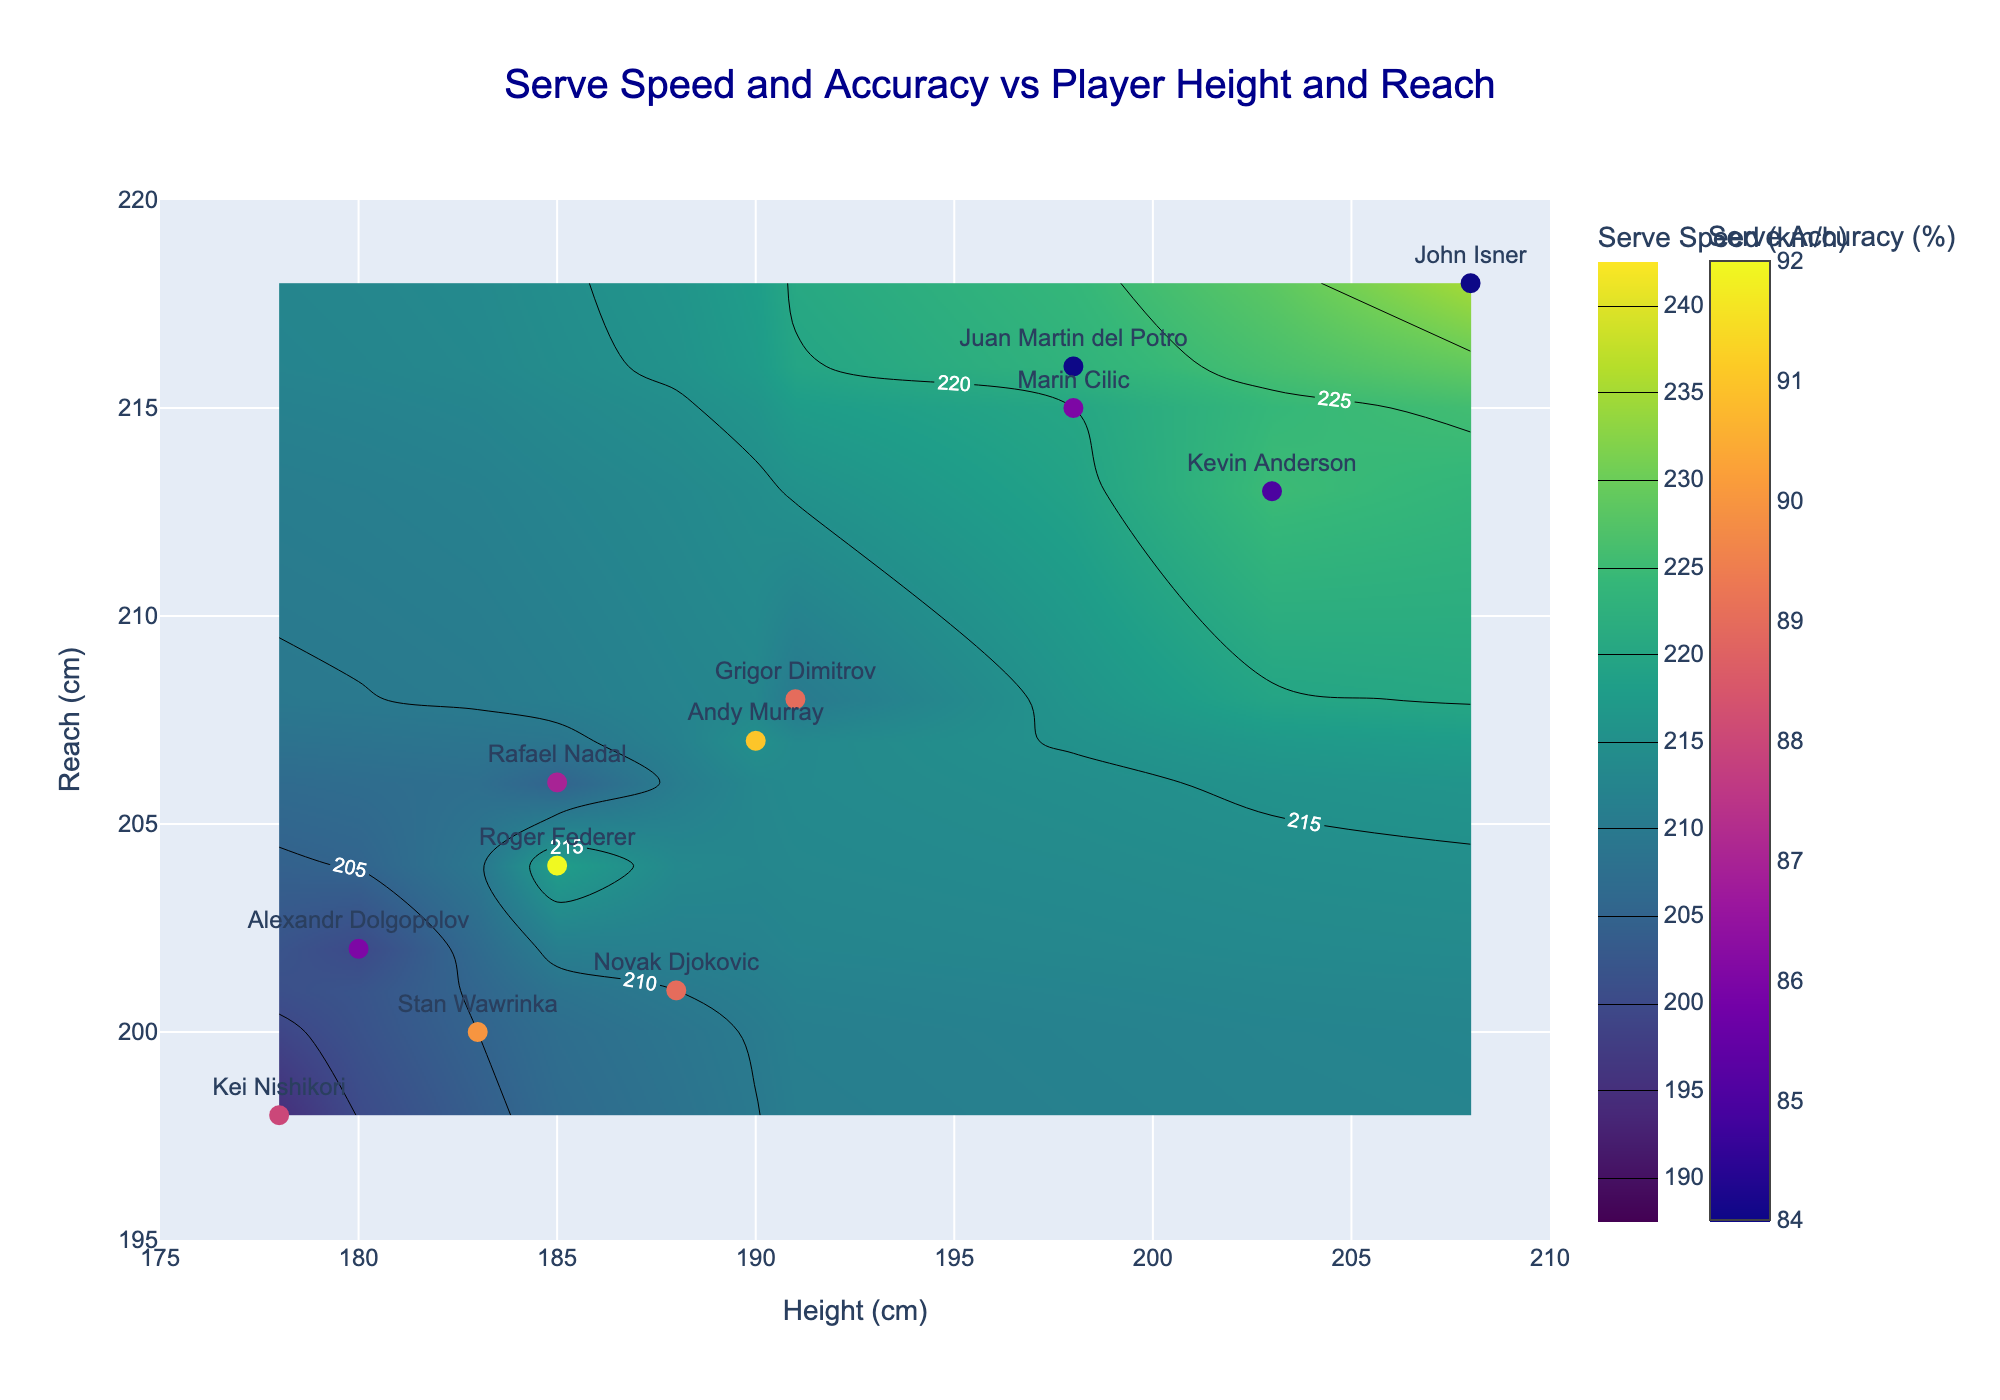What is the title of the figure? The title of the figure is found at the top center of the plot. It reads "Serve Speed and Accuracy vs Player Height and Reach".
Answer: Serve Speed and Accuracy vs Player Height and Reach How many players are shown in the figure? The figure displays data points for each player. Counting the markers on the plot will give the number of players.
Answer: 12 Which player has the highest serve speed? The highest serve speed is shown in the contour plot with the highest z-value (upper range of color in 'Viridis' scale). John Isner's label is placed at the highest serve speed value.
Answer: John Isner Which player has the best serve accuracy? Serve accuracy is represented by the color intensity in Plasma colorscale of player markers. Roger Federer's marker seems to have the highest intensity.
Answer: Roger Federer By how many km/h does Novak Djokovic’s serve speed differ from Kei Nishikori’s? From the plot, Novak Djokovic’s serve speed is 210 km/h, while Kei Nishikori’s is 195 km/h. The difference is calculated as 210 - 195.
Answer: 15 km/h What serve speed range does the contour plot cover? The contour plot's color bar for serve speed provides this information. It ranges from 190 km/h to 240 km/h.
Answer: 190 to 240 km/h Which player has the greatest reach and how does his serve accuracy compare to Rafael Nadal's? John Isner has the greatest reach (highest Y position). His serve accuracy color indicates a lower value (~84%) than Rafael Nadal's (~87%).
Answer: John Isner, lower than Rafael Nadal's Are taller players generally faster servers according to the figure? By observing the correlation between player height on x-axis and the colored contours for serve speed, it appears taller players like John Isner and Kevin Anderson generally reside in upper serve speed regions.
Answer: Yes What is the height of the player with the lowest serve speed? Alexandr Dolgopolov has the lowest serve speed (around 200 km/h), as inferred from the contour colours, and his height value is taken from his marker’s x position.
Answer: 180 cm Which two players have similar heights but different reach? Rafael Nadal and Roger Federer have similar heights (both around 185 cm) but different reaches. Nadal's reach is about 206 cm, and Federer’s is about 204 cm.
Answer: Rafael Nadal and Roger Federer 